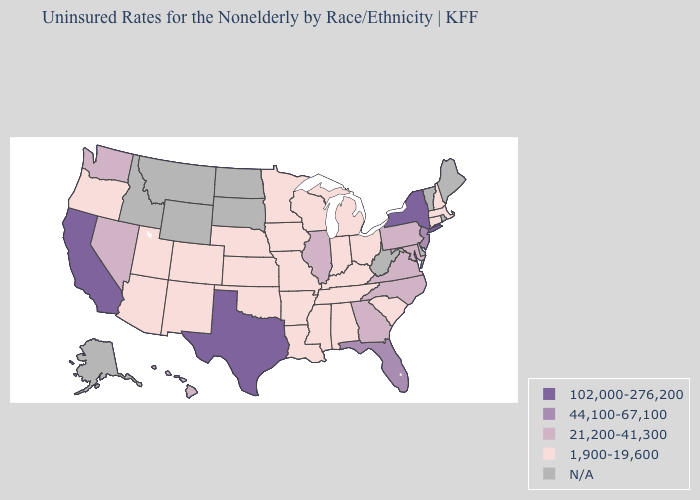Does New York have the highest value in the USA?
Keep it brief. Yes. Among the states that border New York , does New Jersey have the lowest value?
Be succinct. No. What is the highest value in states that border Wyoming?
Short answer required. 1,900-19,600. What is the value of Missouri?
Quick response, please. 1,900-19,600. Does New York have the highest value in the USA?
Keep it brief. Yes. What is the value of Colorado?
Quick response, please. 1,900-19,600. What is the value of New York?
Short answer required. 102,000-276,200. What is the value of North Dakota?
Give a very brief answer. N/A. Does the map have missing data?
Be succinct. Yes. What is the highest value in the Northeast ?
Be succinct. 102,000-276,200. Does Connecticut have the highest value in the Northeast?
Write a very short answer. No. 